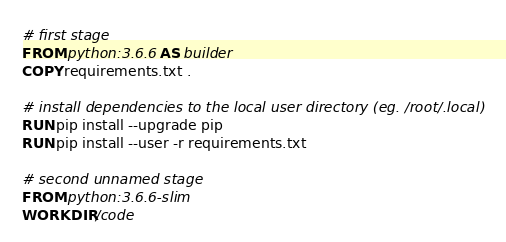<code> <loc_0><loc_0><loc_500><loc_500><_Dockerfile_># first stage
FROM python:3.6.6 AS builder
COPY requirements.txt .

# install dependencies to the local user directory (eg. /root/.local)
RUN pip install --upgrade pip
RUN pip install --user -r requirements.txt

# second unnamed stage
FROM python:3.6.6-slim
WORKDIR /code
</code> 